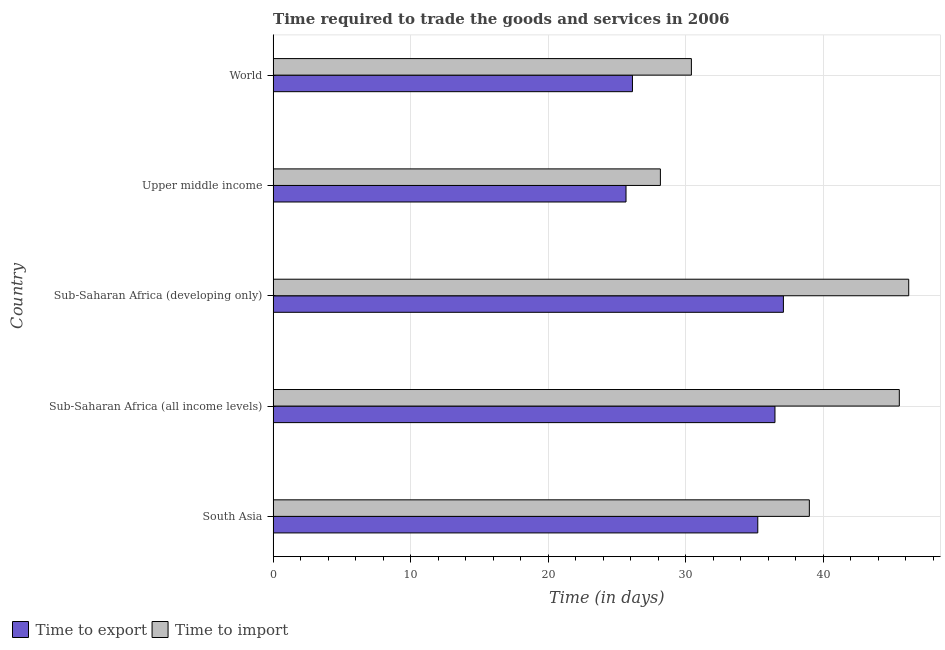How many bars are there on the 4th tick from the bottom?
Your answer should be very brief. 2. What is the label of the 3rd group of bars from the top?
Ensure brevity in your answer.  Sub-Saharan Africa (developing only). In how many cases, is the number of bars for a given country not equal to the number of legend labels?
Make the answer very short. 0. What is the time to export in Upper middle income?
Make the answer very short. 25.67. Across all countries, what is the maximum time to import?
Provide a short and direct response. 46.23. Across all countries, what is the minimum time to import?
Make the answer very short. 28.17. In which country was the time to import maximum?
Your answer should be very brief. Sub-Saharan Africa (developing only). In which country was the time to import minimum?
Give a very brief answer. Upper middle income. What is the total time to import in the graph?
Your answer should be compact. 189.36. What is the difference between the time to import in Upper middle income and that in World?
Ensure brevity in your answer.  -2.25. What is the difference between the time to export in World and the time to import in Sub-Saharan Africa (all income levels)?
Give a very brief answer. -19.41. What is the average time to export per country?
Offer a very short reply. 32.13. In how many countries, is the time to import greater than 28 days?
Your answer should be very brief. 5. Is the difference between the time to import in Sub-Saharan Africa (developing only) and World greater than the difference between the time to export in Sub-Saharan Africa (developing only) and World?
Provide a short and direct response. Yes. What is the difference between the highest and the second highest time to import?
Give a very brief answer. 0.68. What is the difference between the highest and the lowest time to import?
Your answer should be very brief. 18.06. In how many countries, is the time to export greater than the average time to export taken over all countries?
Your answer should be very brief. 3. Is the sum of the time to import in South Asia and World greater than the maximum time to export across all countries?
Provide a short and direct response. Yes. What does the 2nd bar from the top in World represents?
Your answer should be very brief. Time to export. What does the 1st bar from the bottom in Sub-Saharan Africa (developing only) represents?
Offer a very short reply. Time to export. How many bars are there?
Provide a short and direct response. 10. What is the difference between two consecutive major ticks on the X-axis?
Your answer should be compact. 10. Are the values on the major ticks of X-axis written in scientific E-notation?
Your answer should be compact. No. Does the graph contain grids?
Ensure brevity in your answer.  Yes. What is the title of the graph?
Ensure brevity in your answer.  Time required to trade the goods and services in 2006. What is the label or title of the X-axis?
Ensure brevity in your answer.  Time (in days). What is the label or title of the Y-axis?
Make the answer very short. Country. What is the Time (in days) of Time to export in South Asia?
Provide a short and direct response. 35.25. What is the Time (in days) in Time to import in South Asia?
Keep it short and to the point. 39. What is the Time (in days) of Time to export in Sub-Saharan Africa (all income levels)?
Give a very brief answer. 36.5. What is the Time (in days) of Time to import in Sub-Saharan Africa (all income levels)?
Your response must be concise. 45.54. What is the Time (in days) in Time to export in Sub-Saharan Africa (developing only)?
Provide a short and direct response. 37.11. What is the Time (in days) in Time to import in Sub-Saharan Africa (developing only)?
Provide a short and direct response. 46.23. What is the Time (in days) of Time to export in Upper middle income?
Your answer should be very brief. 25.67. What is the Time (in days) of Time to import in Upper middle income?
Keep it short and to the point. 28.17. What is the Time (in days) in Time to export in World?
Your response must be concise. 26.13. What is the Time (in days) of Time to import in World?
Ensure brevity in your answer.  30.42. Across all countries, what is the maximum Time (in days) in Time to export?
Make the answer very short. 37.11. Across all countries, what is the maximum Time (in days) in Time to import?
Offer a very short reply. 46.23. Across all countries, what is the minimum Time (in days) in Time to export?
Offer a very short reply. 25.67. Across all countries, what is the minimum Time (in days) in Time to import?
Keep it short and to the point. 28.17. What is the total Time (in days) of Time to export in the graph?
Provide a short and direct response. 160.67. What is the total Time (in days) of Time to import in the graph?
Your response must be concise. 189.36. What is the difference between the Time (in days) in Time to export in South Asia and that in Sub-Saharan Africa (all income levels)?
Your answer should be very brief. -1.25. What is the difference between the Time (in days) in Time to import in South Asia and that in Sub-Saharan Africa (all income levels)?
Provide a succinct answer. -6.54. What is the difference between the Time (in days) in Time to export in South Asia and that in Sub-Saharan Africa (developing only)?
Provide a short and direct response. -1.86. What is the difference between the Time (in days) of Time to import in South Asia and that in Sub-Saharan Africa (developing only)?
Ensure brevity in your answer.  -7.23. What is the difference between the Time (in days) in Time to export in South Asia and that in Upper middle income?
Keep it short and to the point. 9.58. What is the difference between the Time (in days) in Time to import in South Asia and that in Upper middle income?
Give a very brief answer. 10.83. What is the difference between the Time (in days) in Time to export in South Asia and that in World?
Your response must be concise. 9.12. What is the difference between the Time (in days) in Time to import in South Asia and that in World?
Offer a terse response. 8.58. What is the difference between the Time (in days) of Time to export in Sub-Saharan Africa (all income levels) and that in Sub-Saharan Africa (developing only)?
Make the answer very short. -0.61. What is the difference between the Time (in days) in Time to import in Sub-Saharan Africa (all income levels) and that in Sub-Saharan Africa (developing only)?
Your response must be concise. -0.68. What is the difference between the Time (in days) in Time to export in Sub-Saharan Africa (all income levels) and that in Upper middle income?
Your answer should be compact. 10.83. What is the difference between the Time (in days) in Time to import in Sub-Saharan Africa (all income levels) and that in Upper middle income?
Offer a terse response. 17.38. What is the difference between the Time (in days) of Time to export in Sub-Saharan Africa (all income levels) and that in World?
Provide a short and direct response. 10.37. What is the difference between the Time (in days) in Time to import in Sub-Saharan Africa (all income levels) and that in World?
Provide a short and direct response. 15.12. What is the difference between the Time (in days) of Time to export in Sub-Saharan Africa (developing only) and that in Upper middle income?
Offer a very short reply. 11.45. What is the difference between the Time (in days) in Time to import in Sub-Saharan Africa (developing only) and that in Upper middle income?
Offer a very short reply. 18.06. What is the difference between the Time (in days) in Time to export in Sub-Saharan Africa (developing only) and that in World?
Your response must be concise. 10.98. What is the difference between the Time (in days) of Time to import in Sub-Saharan Africa (developing only) and that in World?
Give a very brief answer. 15.81. What is the difference between the Time (in days) of Time to export in Upper middle income and that in World?
Make the answer very short. -0.47. What is the difference between the Time (in days) in Time to import in Upper middle income and that in World?
Your answer should be very brief. -2.25. What is the difference between the Time (in days) of Time to export in South Asia and the Time (in days) of Time to import in Sub-Saharan Africa (all income levels)?
Keep it short and to the point. -10.29. What is the difference between the Time (in days) in Time to export in South Asia and the Time (in days) in Time to import in Sub-Saharan Africa (developing only)?
Offer a very short reply. -10.98. What is the difference between the Time (in days) of Time to export in South Asia and the Time (in days) of Time to import in Upper middle income?
Your answer should be compact. 7.08. What is the difference between the Time (in days) in Time to export in South Asia and the Time (in days) in Time to import in World?
Offer a terse response. 4.83. What is the difference between the Time (in days) in Time to export in Sub-Saharan Africa (all income levels) and the Time (in days) in Time to import in Sub-Saharan Africa (developing only)?
Provide a succinct answer. -9.73. What is the difference between the Time (in days) in Time to export in Sub-Saharan Africa (all income levels) and the Time (in days) in Time to import in Upper middle income?
Ensure brevity in your answer.  8.33. What is the difference between the Time (in days) of Time to export in Sub-Saharan Africa (all income levels) and the Time (in days) of Time to import in World?
Offer a very short reply. 6.08. What is the difference between the Time (in days) of Time to export in Sub-Saharan Africa (developing only) and the Time (in days) of Time to import in Upper middle income?
Provide a short and direct response. 8.95. What is the difference between the Time (in days) of Time to export in Sub-Saharan Africa (developing only) and the Time (in days) of Time to import in World?
Your response must be concise. 6.69. What is the difference between the Time (in days) of Time to export in Upper middle income and the Time (in days) of Time to import in World?
Ensure brevity in your answer.  -4.75. What is the average Time (in days) of Time to export per country?
Give a very brief answer. 32.13. What is the average Time (in days) in Time to import per country?
Offer a terse response. 37.87. What is the difference between the Time (in days) of Time to export and Time (in days) of Time to import in South Asia?
Your response must be concise. -3.75. What is the difference between the Time (in days) in Time to export and Time (in days) in Time to import in Sub-Saharan Africa (all income levels)?
Ensure brevity in your answer.  -9.04. What is the difference between the Time (in days) of Time to export and Time (in days) of Time to import in Sub-Saharan Africa (developing only)?
Your response must be concise. -9.11. What is the difference between the Time (in days) in Time to export and Time (in days) in Time to import in World?
Give a very brief answer. -4.29. What is the ratio of the Time (in days) of Time to export in South Asia to that in Sub-Saharan Africa (all income levels)?
Offer a terse response. 0.97. What is the ratio of the Time (in days) of Time to import in South Asia to that in Sub-Saharan Africa (all income levels)?
Your answer should be very brief. 0.86. What is the ratio of the Time (in days) in Time to export in South Asia to that in Sub-Saharan Africa (developing only)?
Make the answer very short. 0.95. What is the ratio of the Time (in days) of Time to import in South Asia to that in Sub-Saharan Africa (developing only)?
Ensure brevity in your answer.  0.84. What is the ratio of the Time (in days) in Time to export in South Asia to that in Upper middle income?
Your answer should be compact. 1.37. What is the ratio of the Time (in days) of Time to import in South Asia to that in Upper middle income?
Provide a succinct answer. 1.38. What is the ratio of the Time (in days) in Time to export in South Asia to that in World?
Your answer should be very brief. 1.35. What is the ratio of the Time (in days) of Time to import in South Asia to that in World?
Offer a terse response. 1.28. What is the ratio of the Time (in days) in Time to export in Sub-Saharan Africa (all income levels) to that in Sub-Saharan Africa (developing only)?
Make the answer very short. 0.98. What is the ratio of the Time (in days) of Time to import in Sub-Saharan Africa (all income levels) to that in Sub-Saharan Africa (developing only)?
Keep it short and to the point. 0.99. What is the ratio of the Time (in days) in Time to export in Sub-Saharan Africa (all income levels) to that in Upper middle income?
Your answer should be compact. 1.42. What is the ratio of the Time (in days) of Time to import in Sub-Saharan Africa (all income levels) to that in Upper middle income?
Give a very brief answer. 1.62. What is the ratio of the Time (in days) in Time to export in Sub-Saharan Africa (all income levels) to that in World?
Offer a very short reply. 1.4. What is the ratio of the Time (in days) of Time to import in Sub-Saharan Africa (all income levels) to that in World?
Your answer should be very brief. 1.5. What is the ratio of the Time (in days) of Time to export in Sub-Saharan Africa (developing only) to that in Upper middle income?
Make the answer very short. 1.45. What is the ratio of the Time (in days) in Time to import in Sub-Saharan Africa (developing only) to that in Upper middle income?
Offer a terse response. 1.64. What is the ratio of the Time (in days) in Time to export in Sub-Saharan Africa (developing only) to that in World?
Your answer should be compact. 1.42. What is the ratio of the Time (in days) of Time to import in Sub-Saharan Africa (developing only) to that in World?
Make the answer very short. 1.52. What is the ratio of the Time (in days) of Time to export in Upper middle income to that in World?
Provide a short and direct response. 0.98. What is the ratio of the Time (in days) in Time to import in Upper middle income to that in World?
Provide a short and direct response. 0.93. What is the difference between the highest and the second highest Time (in days) of Time to export?
Make the answer very short. 0.61. What is the difference between the highest and the second highest Time (in days) in Time to import?
Provide a short and direct response. 0.68. What is the difference between the highest and the lowest Time (in days) in Time to export?
Ensure brevity in your answer.  11.45. What is the difference between the highest and the lowest Time (in days) in Time to import?
Provide a succinct answer. 18.06. 